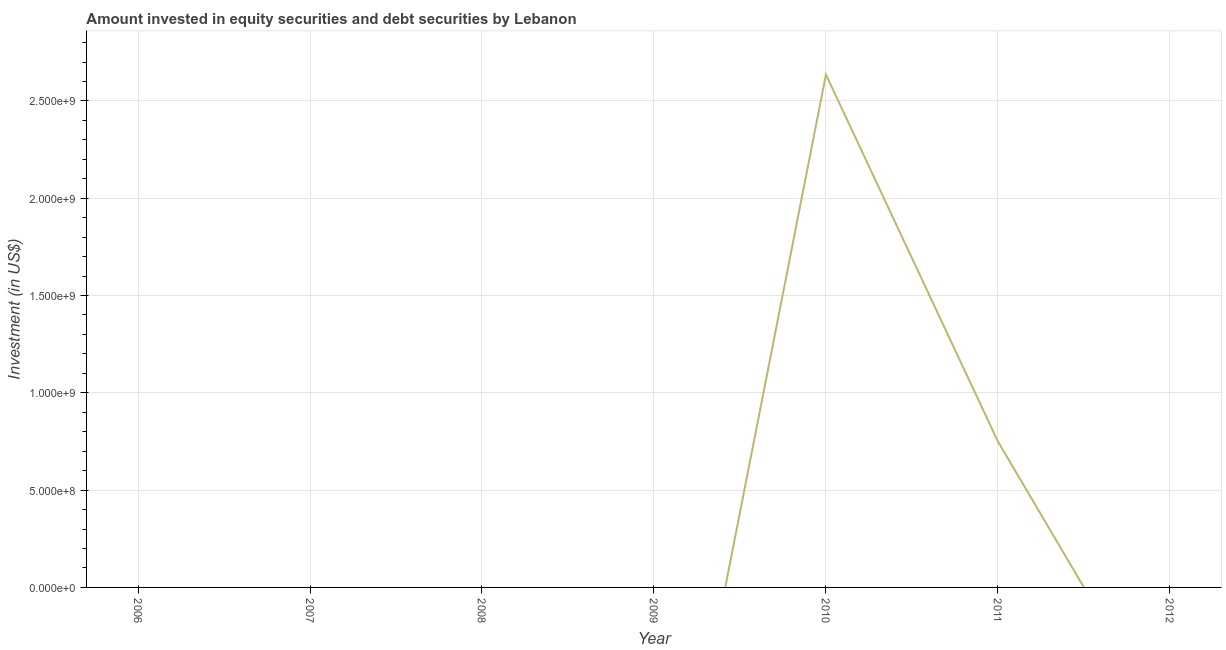What is the portfolio investment in 2011?
Your answer should be very brief. 7.50e+08. Across all years, what is the maximum portfolio investment?
Offer a very short reply. 2.64e+09. In which year was the portfolio investment maximum?
Your response must be concise. 2010. What is the sum of the portfolio investment?
Your answer should be very brief. 3.39e+09. What is the difference between the portfolio investment in 2010 and 2011?
Ensure brevity in your answer.  1.89e+09. What is the average portfolio investment per year?
Give a very brief answer. 4.84e+08. What is the median portfolio investment?
Make the answer very short. 0. What is the ratio of the portfolio investment in 2010 to that in 2011?
Your answer should be very brief. 3.51. What is the difference between the highest and the lowest portfolio investment?
Your answer should be very brief. 2.64e+09. Does the portfolio investment monotonically increase over the years?
Your response must be concise. No. What is the difference between two consecutive major ticks on the Y-axis?
Make the answer very short. 5.00e+08. Does the graph contain any zero values?
Give a very brief answer. Yes. What is the title of the graph?
Provide a succinct answer. Amount invested in equity securities and debt securities by Lebanon. What is the label or title of the X-axis?
Provide a succinct answer. Year. What is the label or title of the Y-axis?
Offer a terse response. Investment (in US$). What is the Investment (in US$) of 2007?
Keep it short and to the point. 0. What is the Investment (in US$) of 2008?
Provide a short and direct response. 0. What is the Investment (in US$) of 2009?
Make the answer very short. 0. What is the Investment (in US$) of 2010?
Make the answer very short. 2.64e+09. What is the Investment (in US$) of 2011?
Keep it short and to the point. 7.50e+08. What is the difference between the Investment (in US$) in 2010 and 2011?
Keep it short and to the point. 1.89e+09. What is the ratio of the Investment (in US$) in 2010 to that in 2011?
Your answer should be very brief. 3.51. 